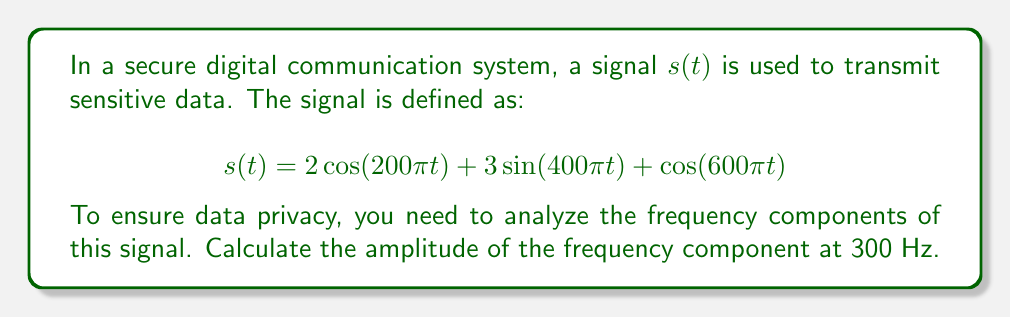Can you solve this math problem? To analyze the frequency components of the given signal, we need to use the Fourier transform. Let's approach this step-by-step:

1) First, recall that the Fourier transform of a cosine or sine function is given by:

   $$\mathcal{F}\{\cos(2\pi f_0 t)\} = \frac{1}{2}[\delta(f-f_0) + \delta(f+f_0)]$$
   $$\mathcal{F}\{\sin(2\pi f_0 t)\} = \frac{1}{2j}[\delta(f-f_0) - \delta(f+f_0)]$$

2) Now, let's break down our signal:

   $$s(t) = 2\cos(200\pi t) + 3\sin(400\pi t) + \cos(600\pi t)$$

3) We can identify the frequencies:
   - $200\pi = 2\pi f_1$, so $f_1 = 100$ Hz
   - $400\pi = 2\pi f_2$, so $f_2 = 200$ Hz
   - $600\pi = 2\pi f_3$, so $f_3 = 300$ Hz

4) Now, let's apply the Fourier transform to each term:

   $$\mathcal{F}\{2\cos(200\pi t)\} = [\delta(f-100) + \delta(f+100)]$$
   $$\mathcal{F}\{3\sin(400\pi t)\} = \frac{3}{2j}[\delta(f-200) - \delta(f+200)]$$
   $$\mathcal{F}\{\cos(600\pi t)\} = \frac{1}{2}[\delta(f-300) + \delta(f+300)]$$

5) The Fourier transform of the entire signal is the sum of these components:

   $$S(f) = [\delta(f-100) + \delta(f+100)] + \frac{3}{2j}[\delta(f-200) - \delta(f+200)] + \frac{1}{2}[\delta(f-300) + \delta(f+300)]$$

6) The question asks for the amplitude of the frequency component at 300 Hz. We can see this in the last term of $S(f)$:

   $$\frac{1}{2}[\delta(f-300) + \delta(f+300)]$$

7) The amplitude of this component is $\frac{1}{2}$.
Answer: The amplitude of the frequency component at 300 Hz is $\frac{1}{2}$ or 0.5. 